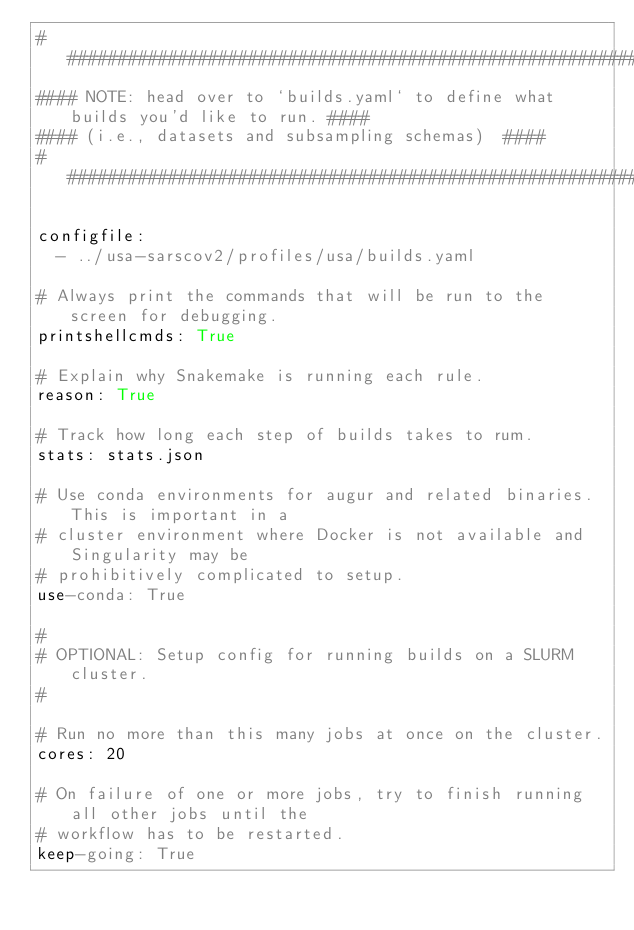Convert code to text. <code><loc_0><loc_0><loc_500><loc_500><_YAML_>#####################################################################################
#### NOTE: head over to `builds.yaml` to define what builds you'd like to run. ####
#### (i.e., datasets and subsampling schemas)  ####
#####################################################################################

configfile:
  - ../usa-sarscov2/profiles/usa/builds.yaml

# Always print the commands that will be run to the screen for debugging.
printshellcmds: True

# Explain why Snakemake is running each rule.
reason: True

# Track how long each step of builds takes to rum.
stats: stats.json

# Use conda environments for augur and related binaries. This is important in a
# cluster environment where Docker is not available and Singularity may be
# prohibitively complicated to setup.
use-conda: True

#
# OPTIONAL: Setup config for running builds on a SLURM cluster.
#

# Run no more than this many jobs at once on the cluster.
cores: 20

# On failure of one or more jobs, try to finish running all other jobs until the
# workflow has to be restarted.
keep-going: True
</code> 